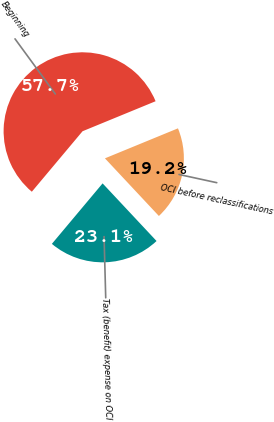Convert chart. <chart><loc_0><loc_0><loc_500><loc_500><pie_chart><fcel>Beginning<fcel>OCI before reclassifications<fcel>Tax (benefit) expense on OCI<nl><fcel>57.69%<fcel>19.23%<fcel>23.08%<nl></chart> 